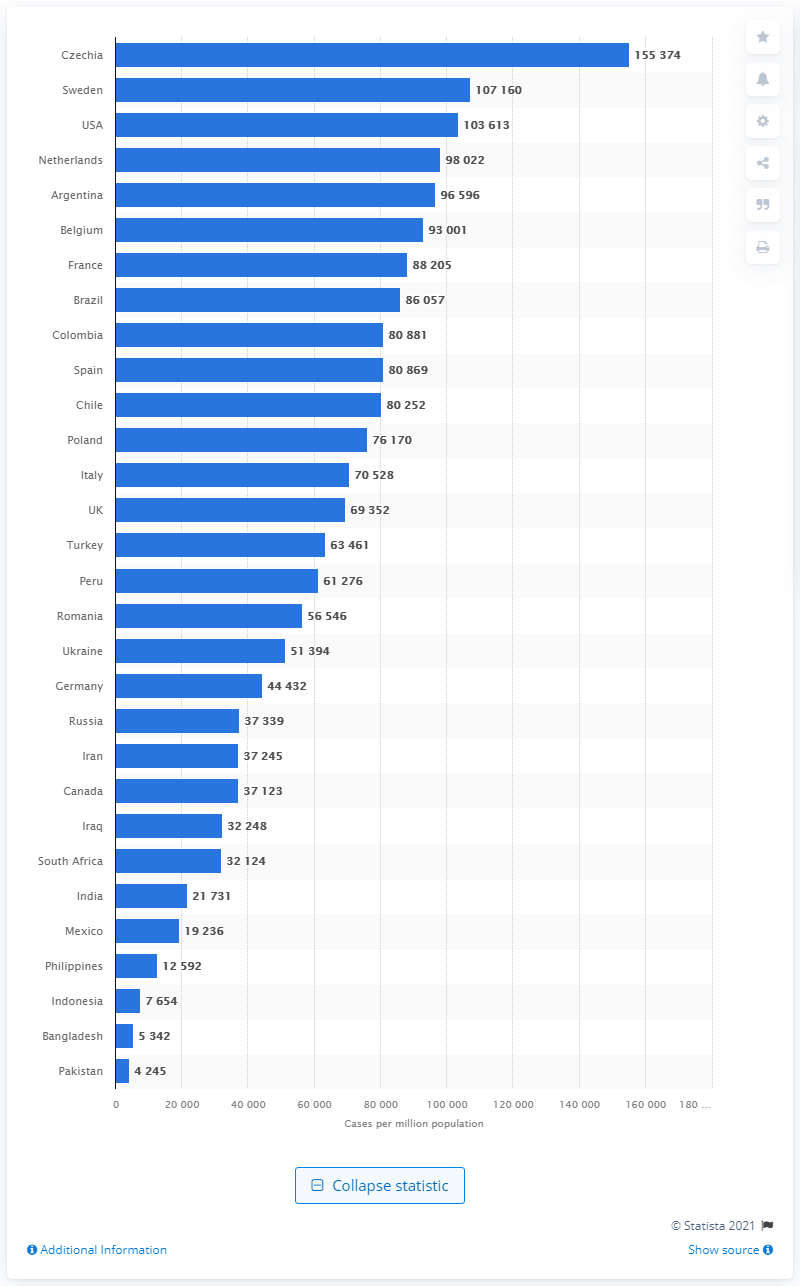Mention a couple of crucial points in this snapshot. The country with the highest rate of COVID-19 cases among the countries most affected by the pandemic was Czechia. 